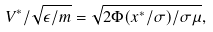Convert formula to latex. <formula><loc_0><loc_0><loc_500><loc_500>V ^ { * } / \sqrt { \epsilon / m } = \sqrt { 2 \Phi ( x ^ { * } / \sigma ) / \sigma \mu } ,</formula> 